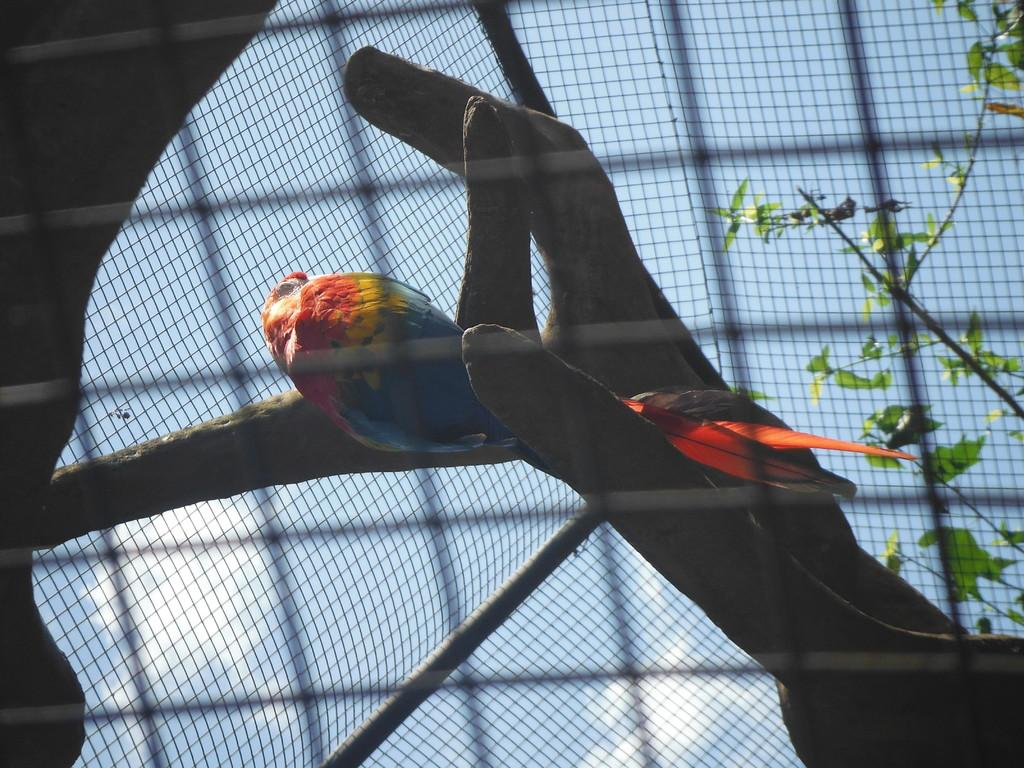What type of animal is in the image? There is a parrot in the image. Where is the parrot located? The parrot is on a branch in the image. What is the branch attached to? The branch is attached to a tree in the image. What can be seen in the background of the image? There is a mesh and the sky visible in the background of the image. What type of mask is the parrot wearing in the image? There is no mask present on the parrot in the image. What order of animals does the parrot belong to? The parrot belongs to the order Psittaciformes, but this information is not directly visible in the image. 